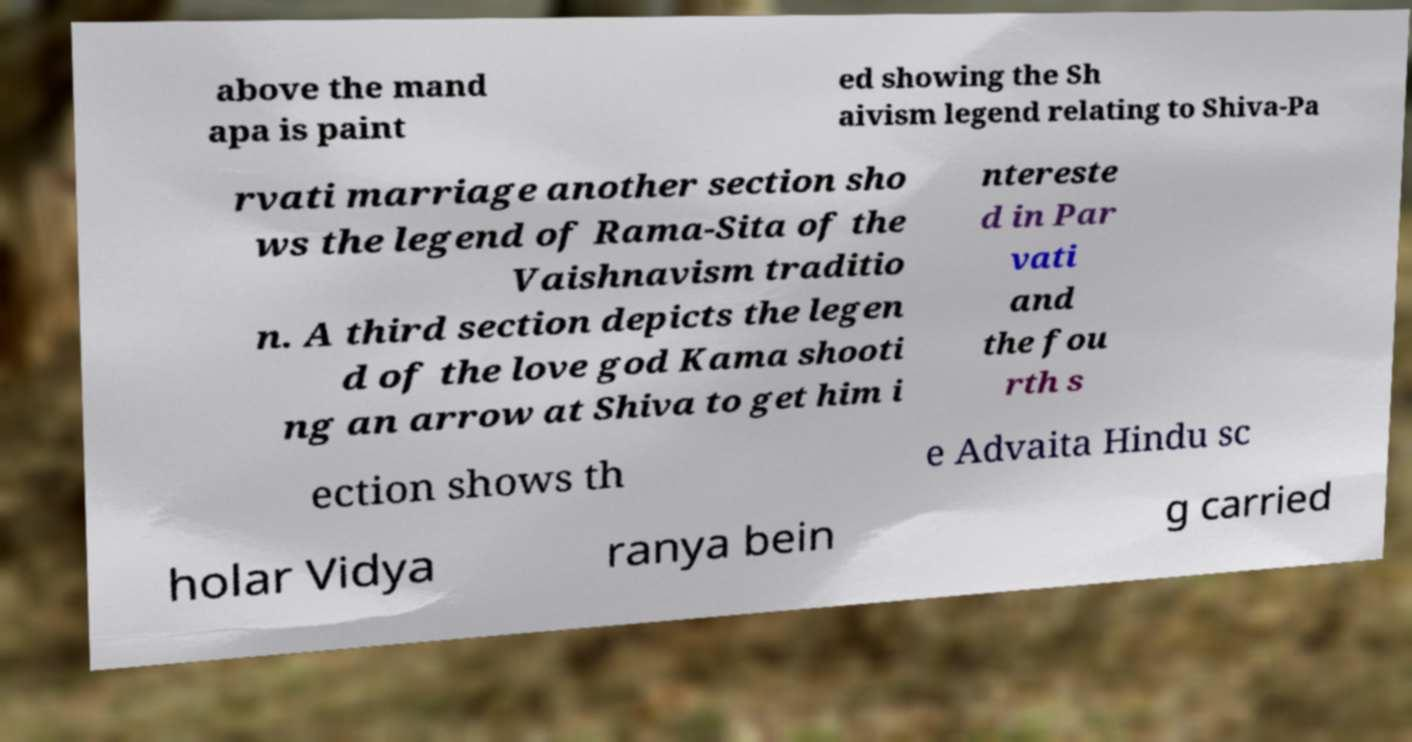Can you read and provide the text displayed in the image?This photo seems to have some interesting text. Can you extract and type it out for me? above the mand apa is paint ed showing the Sh aivism legend relating to Shiva-Pa rvati marriage another section sho ws the legend of Rama-Sita of the Vaishnavism traditio n. A third section depicts the legen d of the love god Kama shooti ng an arrow at Shiva to get him i ntereste d in Par vati and the fou rth s ection shows th e Advaita Hindu sc holar Vidya ranya bein g carried 